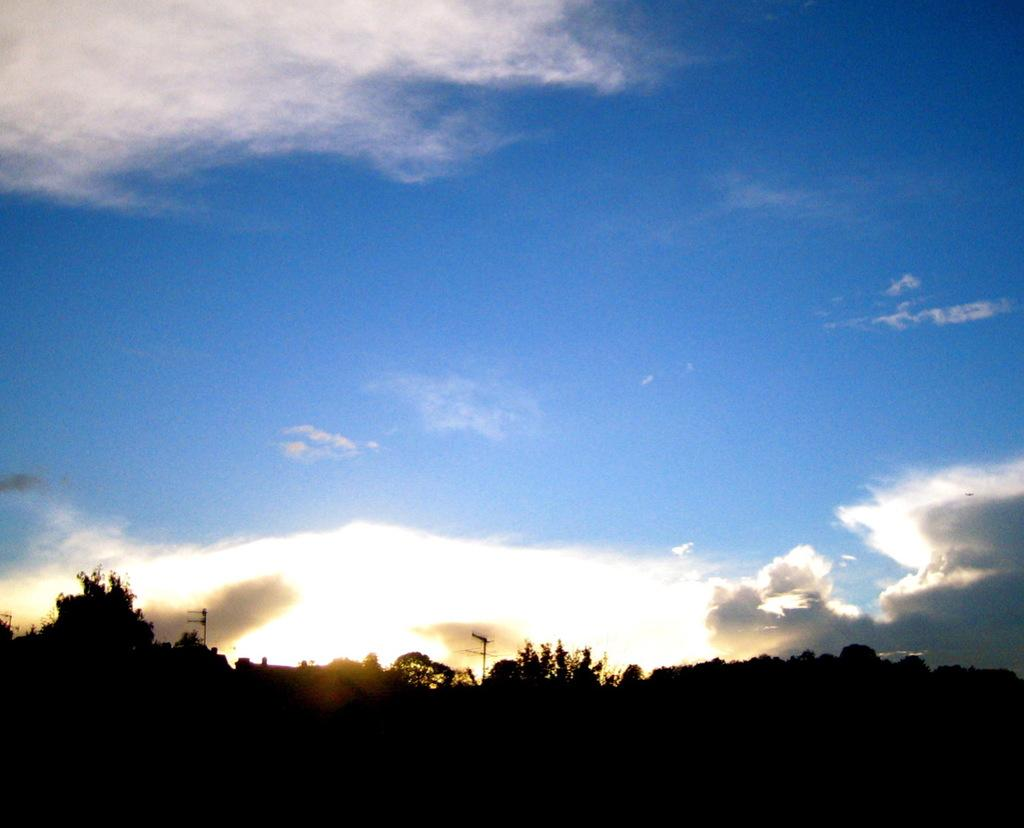What type of vegetation is at the bottom of the image? There are trees at the bottom of the image. What structures can be seen in the middle of the image? There are two electricity poles in the middle of the image. What is the condition of the sky in the image? The sky is cloudy and blue at the top of the image. What type of bread is being used as a caption for the image? There is no bread or caption present in the image. What team is visible in the image? There is no team visible in the image. 